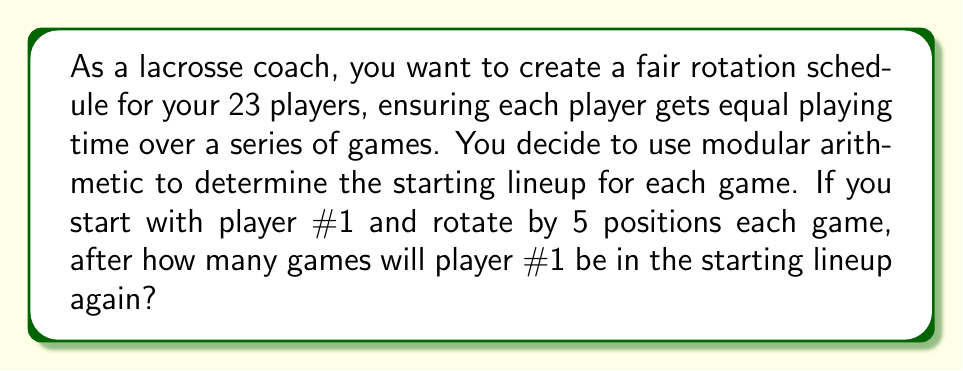Can you solve this math problem? Let's approach this step-by-step using modular arithmetic:

1) We have 23 players, so we're working in modulo 23.

2) Each game, we rotate by 5 positions. This means we're adding 5 (mod 23) each time.

3) We want to find the smallest positive integer $n$ such that:

   $$5n \equiv 0 \pmod{23}$$

4) This is equivalent to solving:

   $$5n = 23k$$ 
   
   for some integer $k$.

5) The smallest positive $n$ that satisfies this is the multiplicative order of 5 modulo 23.

6) We can calculate this by listing the powers of 5 modulo 23:

   $5^1 \equiv 5 \pmod{23}$
   $5^2 \equiv 25 \equiv 2 \pmod{23}$
   $5^3 \equiv 10 \pmod{23}$
   $5^4 \equiv 50 \equiv 4 \pmod{23}$
   ...
   $5^{22} \equiv 1 \pmod{23}$

7) We see that $5^{22} \equiv 1 \pmod{23}$, which means that $5^{23} \equiv 5 \pmod{23}$.

8) Therefore, the multiplicative order of 5 modulo 23 is 22.

This means that after 22 games, player #1 will be back in the starting lineup.
Answer: 22 games 